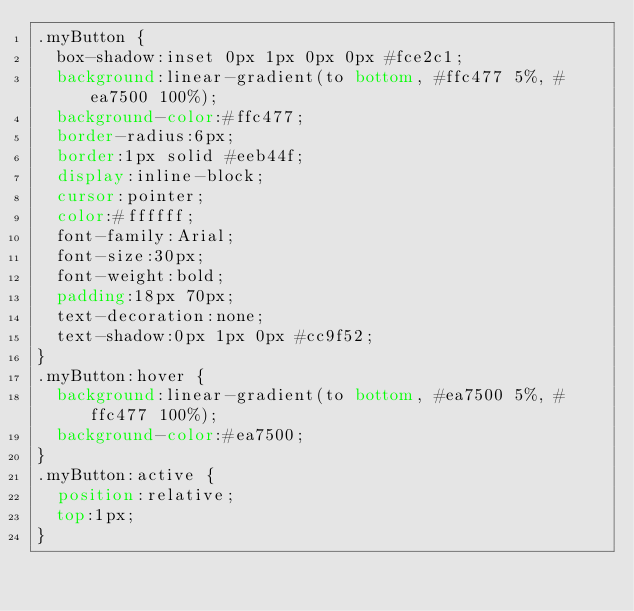<code> <loc_0><loc_0><loc_500><loc_500><_CSS_>.myButton {
	box-shadow:inset 0px 1px 0px 0px #fce2c1;
	background:linear-gradient(to bottom, #ffc477 5%, #ea7500 100%);
	background-color:#ffc477;
	border-radius:6px;
	border:1px solid #eeb44f;
	display:inline-block;
	cursor:pointer;
	color:#ffffff;
	font-family:Arial;
	font-size:30px;
	font-weight:bold;
	padding:18px 70px;
	text-decoration:none;
	text-shadow:0px 1px 0px #cc9f52;
}
.myButton:hover {
	background:linear-gradient(to bottom, #ea7500 5%, #ffc477 100%);
	background-color:#ea7500;
}
.myButton:active {
	position:relative;
	top:1px;
}
</code> 